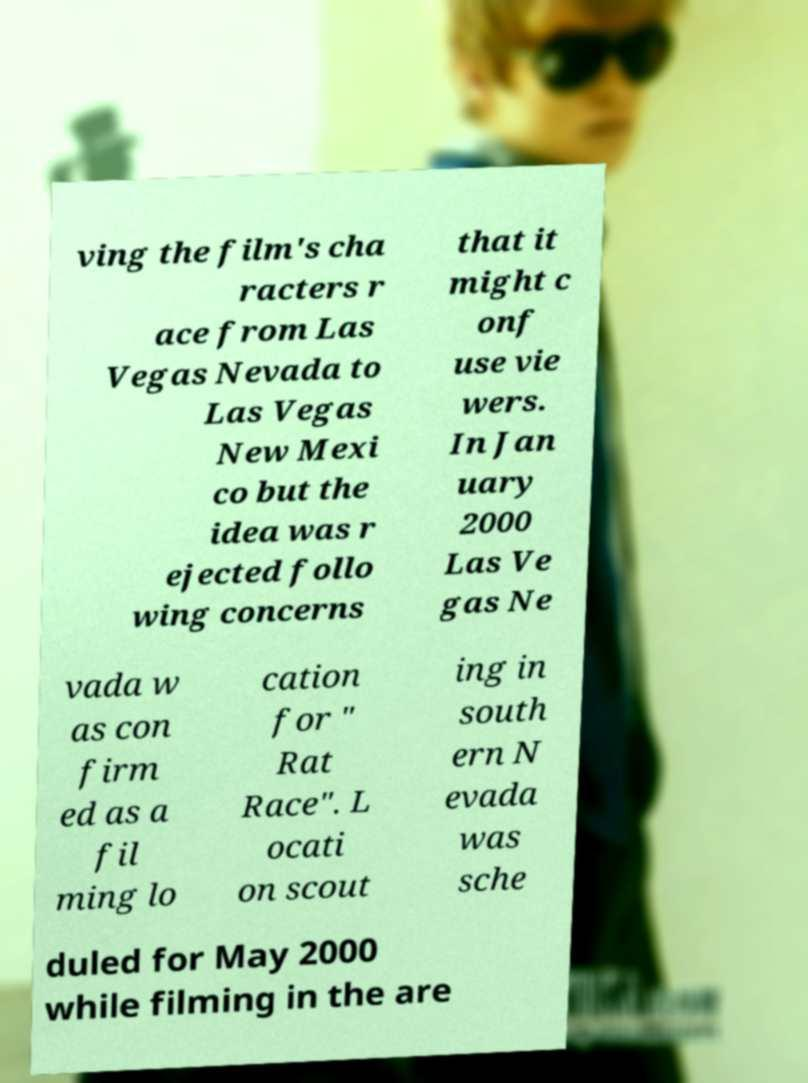There's text embedded in this image that I need extracted. Can you transcribe it verbatim? ving the film's cha racters r ace from Las Vegas Nevada to Las Vegas New Mexi co but the idea was r ejected follo wing concerns that it might c onf use vie wers. In Jan uary 2000 Las Ve gas Ne vada w as con firm ed as a fil ming lo cation for " Rat Race". L ocati on scout ing in south ern N evada was sche duled for May 2000 while filming in the are 